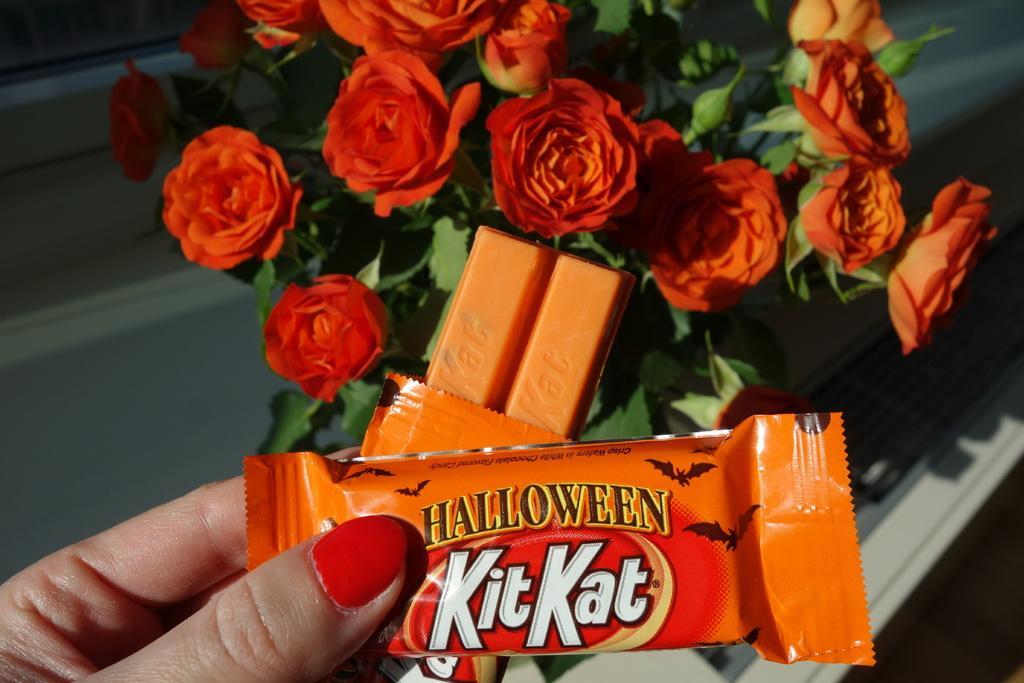Can you describe this image briefly? Here we can see hand of a person holding chocolates. There are flowers and leaves. 